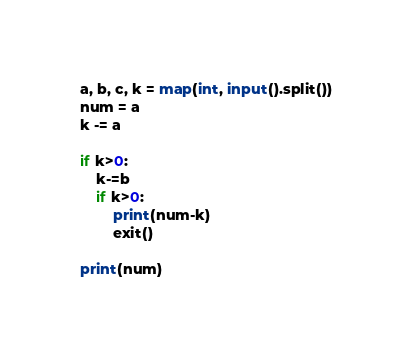Convert code to text. <code><loc_0><loc_0><loc_500><loc_500><_Python_>a, b, c, k = map(int, input().split())
num = a
k -= a

if k>0:
    k-=b
    if k>0:
        print(num-k)
        exit()

print(num)</code> 